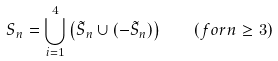<formula> <loc_0><loc_0><loc_500><loc_500>S _ { n } = \bigcup _ { i = 1 } ^ { 4 } \left ( \tilde { S } _ { n } \cup ( - \tilde { S } _ { n } ) \right ) \quad ( f o r n \geq 3 )</formula> 